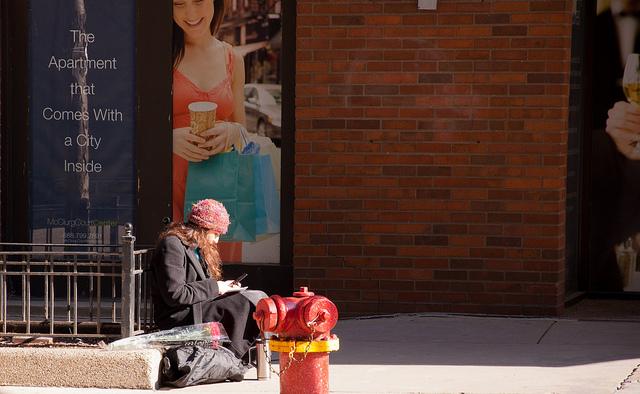What is the woman on the advertisement holding?
Concise answer only. Cup. Is there a fire hydrant on the sidewalk?
Short answer required. Yes. IS there a brick wall in this photo?
Write a very short answer. Yes. 